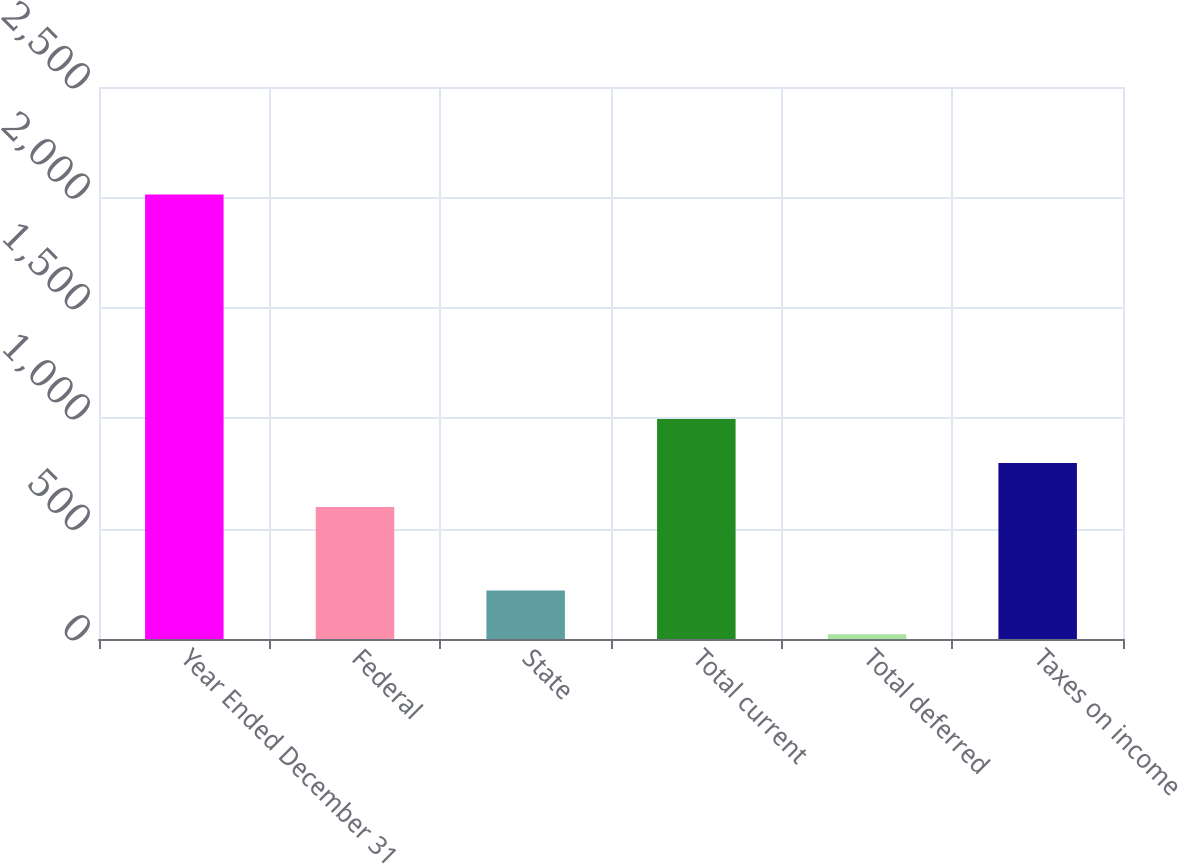<chart> <loc_0><loc_0><loc_500><loc_500><bar_chart><fcel>Year Ended December 31<fcel>Federal<fcel>State<fcel>Total current<fcel>Total deferred<fcel>Taxes on income<nl><fcel>2013<fcel>598<fcel>220.2<fcel>996.4<fcel>21<fcel>797.2<nl></chart> 